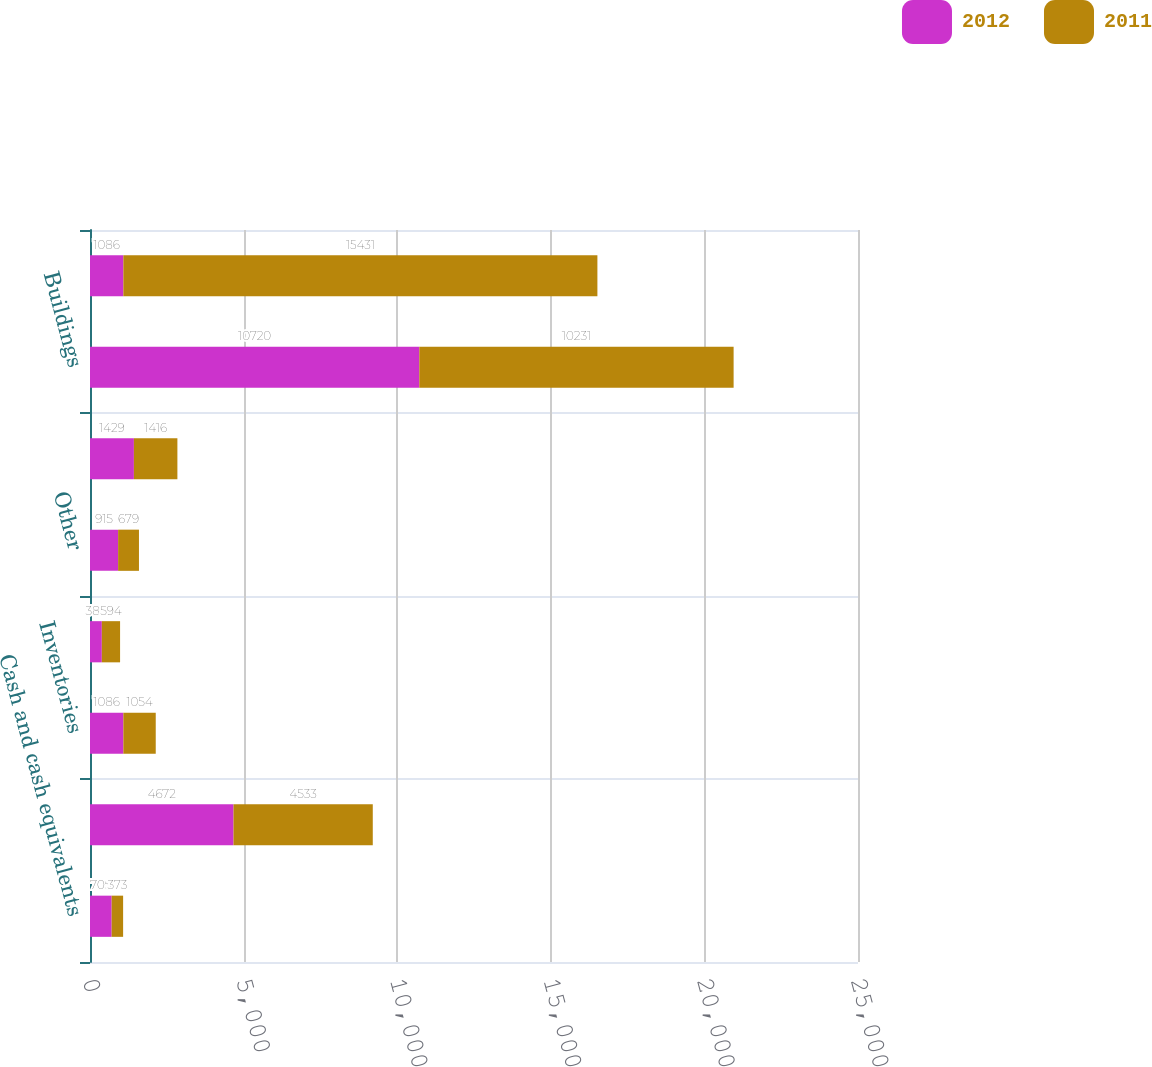<chart> <loc_0><loc_0><loc_500><loc_500><stacked_bar_chart><ecel><fcel>Cash and cash equivalents<fcel>Accounts receivable less<fcel>Inventories<fcel>Deferred income taxes<fcel>Other<fcel>Land<fcel>Buildings<fcel>Equipment<nl><fcel>2012<fcel>705<fcel>4672<fcel>1086<fcel>385<fcel>915<fcel>1429<fcel>10720<fcel>1086<nl><fcel>2011<fcel>373<fcel>4533<fcel>1054<fcel>594<fcel>679<fcel>1416<fcel>10231<fcel>15431<nl></chart> 